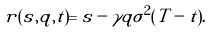Convert formula to latex. <formula><loc_0><loc_0><loc_500><loc_500>r ( s , q , t ) = s - \gamma q \sigma ^ { 2 } ( T - t ) .</formula> 